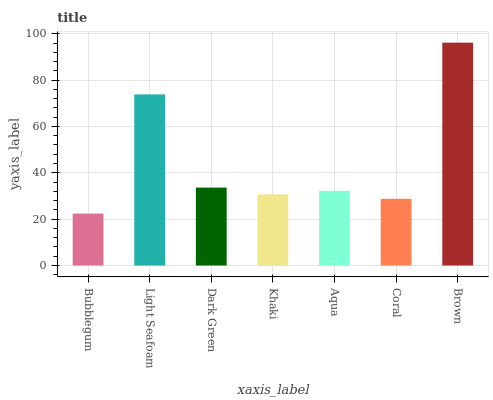Is Bubblegum the minimum?
Answer yes or no. Yes. Is Brown the maximum?
Answer yes or no. Yes. Is Light Seafoam the minimum?
Answer yes or no. No. Is Light Seafoam the maximum?
Answer yes or no. No. Is Light Seafoam greater than Bubblegum?
Answer yes or no. Yes. Is Bubblegum less than Light Seafoam?
Answer yes or no. Yes. Is Bubblegum greater than Light Seafoam?
Answer yes or no. No. Is Light Seafoam less than Bubblegum?
Answer yes or no. No. Is Aqua the high median?
Answer yes or no. Yes. Is Aqua the low median?
Answer yes or no. Yes. Is Bubblegum the high median?
Answer yes or no. No. Is Light Seafoam the low median?
Answer yes or no. No. 